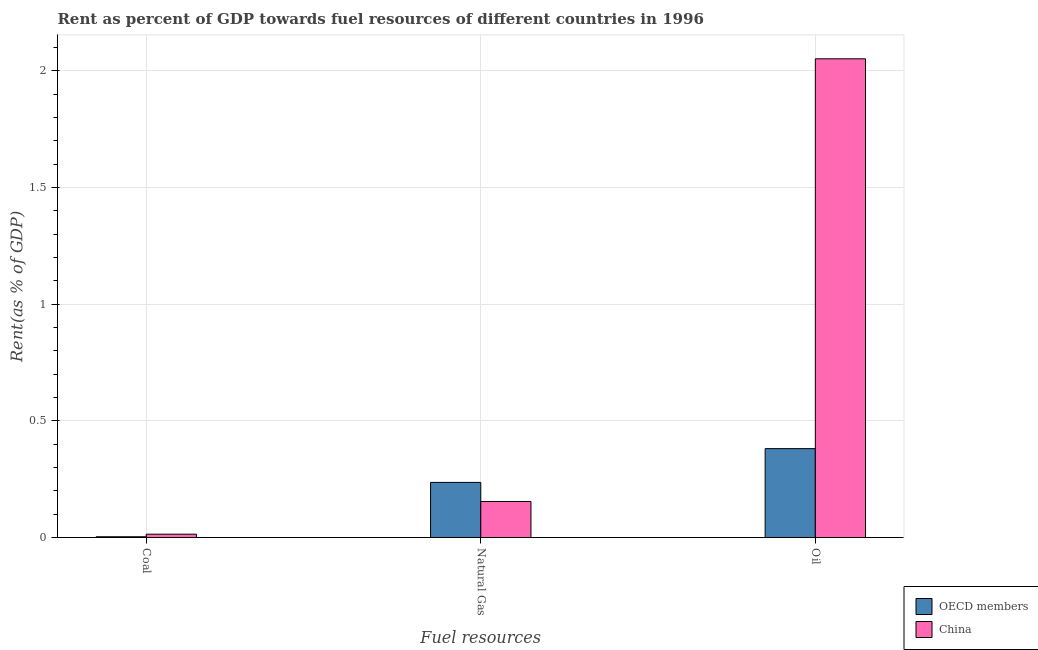How many different coloured bars are there?
Your response must be concise. 2. How many groups of bars are there?
Ensure brevity in your answer.  3. How many bars are there on the 1st tick from the left?
Give a very brief answer. 2. How many bars are there on the 1st tick from the right?
Ensure brevity in your answer.  2. What is the label of the 3rd group of bars from the left?
Your response must be concise. Oil. What is the rent towards oil in China?
Ensure brevity in your answer.  2.05. Across all countries, what is the maximum rent towards natural gas?
Offer a terse response. 0.24. Across all countries, what is the minimum rent towards oil?
Provide a short and direct response. 0.38. In which country was the rent towards oil maximum?
Ensure brevity in your answer.  China. In which country was the rent towards coal minimum?
Give a very brief answer. OECD members. What is the total rent towards natural gas in the graph?
Provide a short and direct response. 0.39. What is the difference between the rent towards natural gas in OECD members and that in China?
Keep it short and to the point. 0.08. What is the difference between the rent towards natural gas in China and the rent towards oil in OECD members?
Ensure brevity in your answer.  -0.23. What is the average rent towards natural gas per country?
Make the answer very short. 0.2. What is the difference between the rent towards coal and rent towards oil in OECD members?
Provide a succinct answer. -0.38. What is the ratio of the rent towards natural gas in OECD members to that in China?
Offer a very short reply. 1.53. Is the difference between the rent towards oil in OECD members and China greater than the difference between the rent towards coal in OECD members and China?
Offer a very short reply. No. What is the difference between the highest and the second highest rent towards coal?
Your answer should be compact. 0.01. What is the difference between the highest and the lowest rent towards oil?
Keep it short and to the point. 1.67. In how many countries, is the rent towards natural gas greater than the average rent towards natural gas taken over all countries?
Provide a short and direct response. 1. What does the 1st bar from the left in Coal represents?
Your response must be concise. OECD members. Is it the case that in every country, the sum of the rent towards coal and rent towards natural gas is greater than the rent towards oil?
Give a very brief answer. No. Are all the bars in the graph horizontal?
Make the answer very short. No. How many countries are there in the graph?
Provide a short and direct response. 2. What is the difference between two consecutive major ticks on the Y-axis?
Make the answer very short. 0.5. Are the values on the major ticks of Y-axis written in scientific E-notation?
Your answer should be very brief. No. Where does the legend appear in the graph?
Give a very brief answer. Bottom right. How many legend labels are there?
Keep it short and to the point. 2. How are the legend labels stacked?
Offer a very short reply. Vertical. What is the title of the graph?
Give a very brief answer. Rent as percent of GDP towards fuel resources of different countries in 1996. Does "Maldives" appear as one of the legend labels in the graph?
Your response must be concise. No. What is the label or title of the X-axis?
Make the answer very short. Fuel resources. What is the label or title of the Y-axis?
Give a very brief answer. Rent(as % of GDP). What is the Rent(as % of GDP) in OECD members in Coal?
Make the answer very short. 0. What is the Rent(as % of GDP) in China in Coal?
Keep it short and to the point. 0.01. What is the Rent(as % of GDP) in OECD members in Natural Gas?
Give a very brief answer. 0.24. What is the Rent(as % of GDP) of China in Natural Gas?
Offer a very short reply. 0.15. What is the Rent(as % of GDP) of OECD members in Oil?
Ensure brevity in your answer.  0.38. What is the Rent(as % of GDP) of China in Oil?
Your answer should be compact. 2.05. Across all Fuel resources, what is the maximum Rent(as % of GDP) of OECD members?
Your answer should be very brief. 0.38. Across all Fuel resources, what is the maximum Rent(as % of GDP) in China?
Your answer should be compact. 2.05. Across all Fuel resources, what is the minimum Rent(as % of GDP) of OECD members?
Make the answer very short. 0. Across all Fuel resources, what is the minimum Rent(as % of GDP) of China?
Make the answer very short. 0.01. What is the total Rent(as % of GDP) of OECD members in the graph?
Your answer should be compact. 0.62. What is the total Rent(as % of GDP) of China in the graph?
Your response must be concise. 2.22. What is the difference between the Rent(as % of GDP) in OECD members in Coal and that in Natural Gas?
Keep it short and to the point. -0.23. What is the difference between the Rent(as % of GDP) in China in Coal and that in Natural Gas?
Keep it short and to the point. -0.14. What is the difference between the Rent(as % of GDP) in OECD members in Coal and that in Oil?
Your answer should be compact. -0.38. What is the difference between the Rent(as % of GDP) of China in Coal and that in Oil?
Give a very brief answer. -2.04. What is the difference between the Rent(as % of GDP) of OECD members in Natural Gas and that in Oil?
Provide a short and direct response. -0.14. What is the difference between the Rent(as % of GDP) of China in Natural Gas and that in Oil?
Give a very brief answer. -1.9. What is the difference between the Rent(as % of GDP) of OECD members in Coal and the Rent(as % of GDP) of China in Natural Gas?
Ensure brevity in your answer.  -0.15. What is the difference between the Rent(as % of GDP) of OECD members in Coal and the Rent(as % of GDP) of China in Oil?
Give a very brief answer. -2.05. What is the difference between the Rent(as % of GDP) in OECD members in Natural Gas and the Rent(as % of GDP) in China in Oil?
Your answer should be very brief. -1.82. What is the average Rent(as % of GDP) in OECD members per Fuel resources?
Ensure brevity in your answer.  0.21. What is the average Rent(as % of GDP) in China per Fuel resources?
Give a very brief answer. 0.74. What is the difference between the Rent(as % of GDP) of OECD members and Rent(as % of GDP) of China in Coal?
Offer a very short reply. -0.01. What is the difference between the Rent(as % of GDP) in OECD members and Rent(as % of GDP) in China in Natural Gas?
Your answer should be very brief. 0.08. What is the difference between the Rent(as % of GDP) of OECD members and Rent(as % of GDP) of China in Oil?
Make the answer very short. -1.67. What is the ratio of the Rent(as % of GDP) in OECD members in Coal to that in Natural Gas?
Make the answer very short. 0.01. What is the ratio of the Rent(as % of GDP) of China in Coal to that in Natural Gas?
Offer a very short reply. 0.09. What is the ratio of the Rent(as % of GDP) in OECD members in Coal to that in Oil?
Your answer should be compact. 0.01. What is the ratio of the Rent(as % of GDP) of China in Coal to that in Oil?
Provide a short and direct response. 0.01. What is the ratio of the Rent(as % of GDP) in OECD members in Natural Gas to that in Oil?
Make the answer very short. 0.62. What is the ratio of the Rent(as % of GDP) of China in Natural Gas to that in Oil?
Offer a terse response. 0.08. What is the difference between the highest and the second highest Rent(as % of GDP) in OECD members?
Make the answer very short. 0.14. What is the difference between the highest and the second highest Rent(as % of GDP) of China?
Ensure brevity in your answer.  1.9. What is the difference between the highest and the lowest Rent(as % of GDP) in OECD members?
Ensure brevity in your answer.  0.38. What is the difference between the highest and the lowest Rent(as % of GDP) in China?
Offer a terse response. 2.04. 